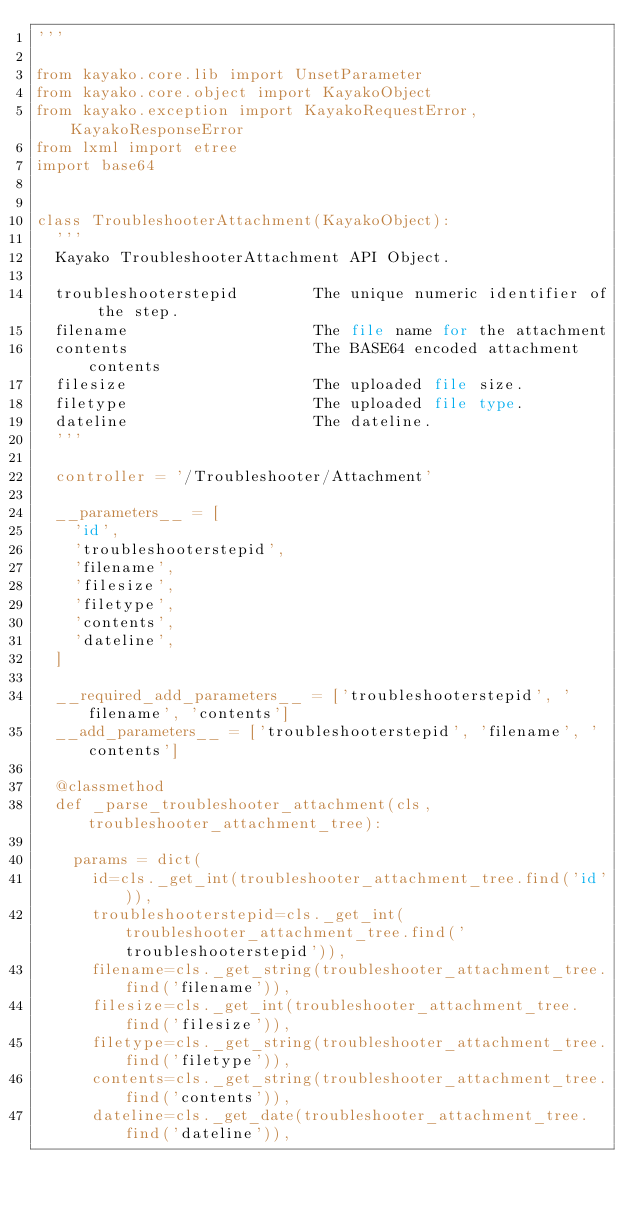Convert code to text. <code><loc_0><loc_0><loc_500><loc_500><_Python_>'''

from kayako.core.lib import UnsetParameter
from kayako.core.object import KayakoObject
from kayako.exception import KayakoRequestError, KayakoResponseError
from lxml import etree
import base64


class TroubleshooterAttachment(KayakoObject):
	'''
	Kayako TroubleshooterAttachment API Object.

	troubleshooterstepid        The unique numeric identifier of the step.
	filename                    The file name for the attachment
	contents                    The BASE64 encoded attachment contents
	filesize                    The uploaded file size.
	filetype                    The uploaded file type.
	dateline                    The dateline.
	'''

	controller = '/Troubleshooter/Attachment'

	__parameters__ = [
		'id',
		'troubleshooterstepid',
		'filename',
		'filesize',
		'filetype',
		'contents',
		'dateline',
	]

	__required_add_parameters__ = ['troubleshooterstepid', 'filename', 'contents']
	__add_parameters__ = ['troubleshooterstepid', 'filename', 'contents']

	@classmethod
	def _parse_troubleshooter_attachment(cls, troubleshooter_attachment_tree):

		params = dict(
			id=cls._get_int(troubleshooter_attachment_tree.find('id')),
			troubleshooterstepid=cls._get_int(troubleshooter_attachment_tree.find('troubleshooterstepid')),
			filename=cls._get_string(troubleshooter_attachment_tree.find('filename')),
			filesize=cls._get_int(troubleshooter_attachment_tree.find('filesize')),
			filetype=cls._get_string(troubleshooter_attachment_tree.find('filetype')),
			contents=cls._get_string(troubleshooter_attachment_tree.find('contents')),
			dateline=cls._get_date(troubleshooter_attachment_tree.find('dateline')),</code> 